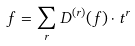Convert formula to latex. <formula><loc_0><loc_0><loc_500><loc_500>f = \sum _ { r } D ^ { ( r ) } ( f ) \cdot t ^ { r }</formula> 